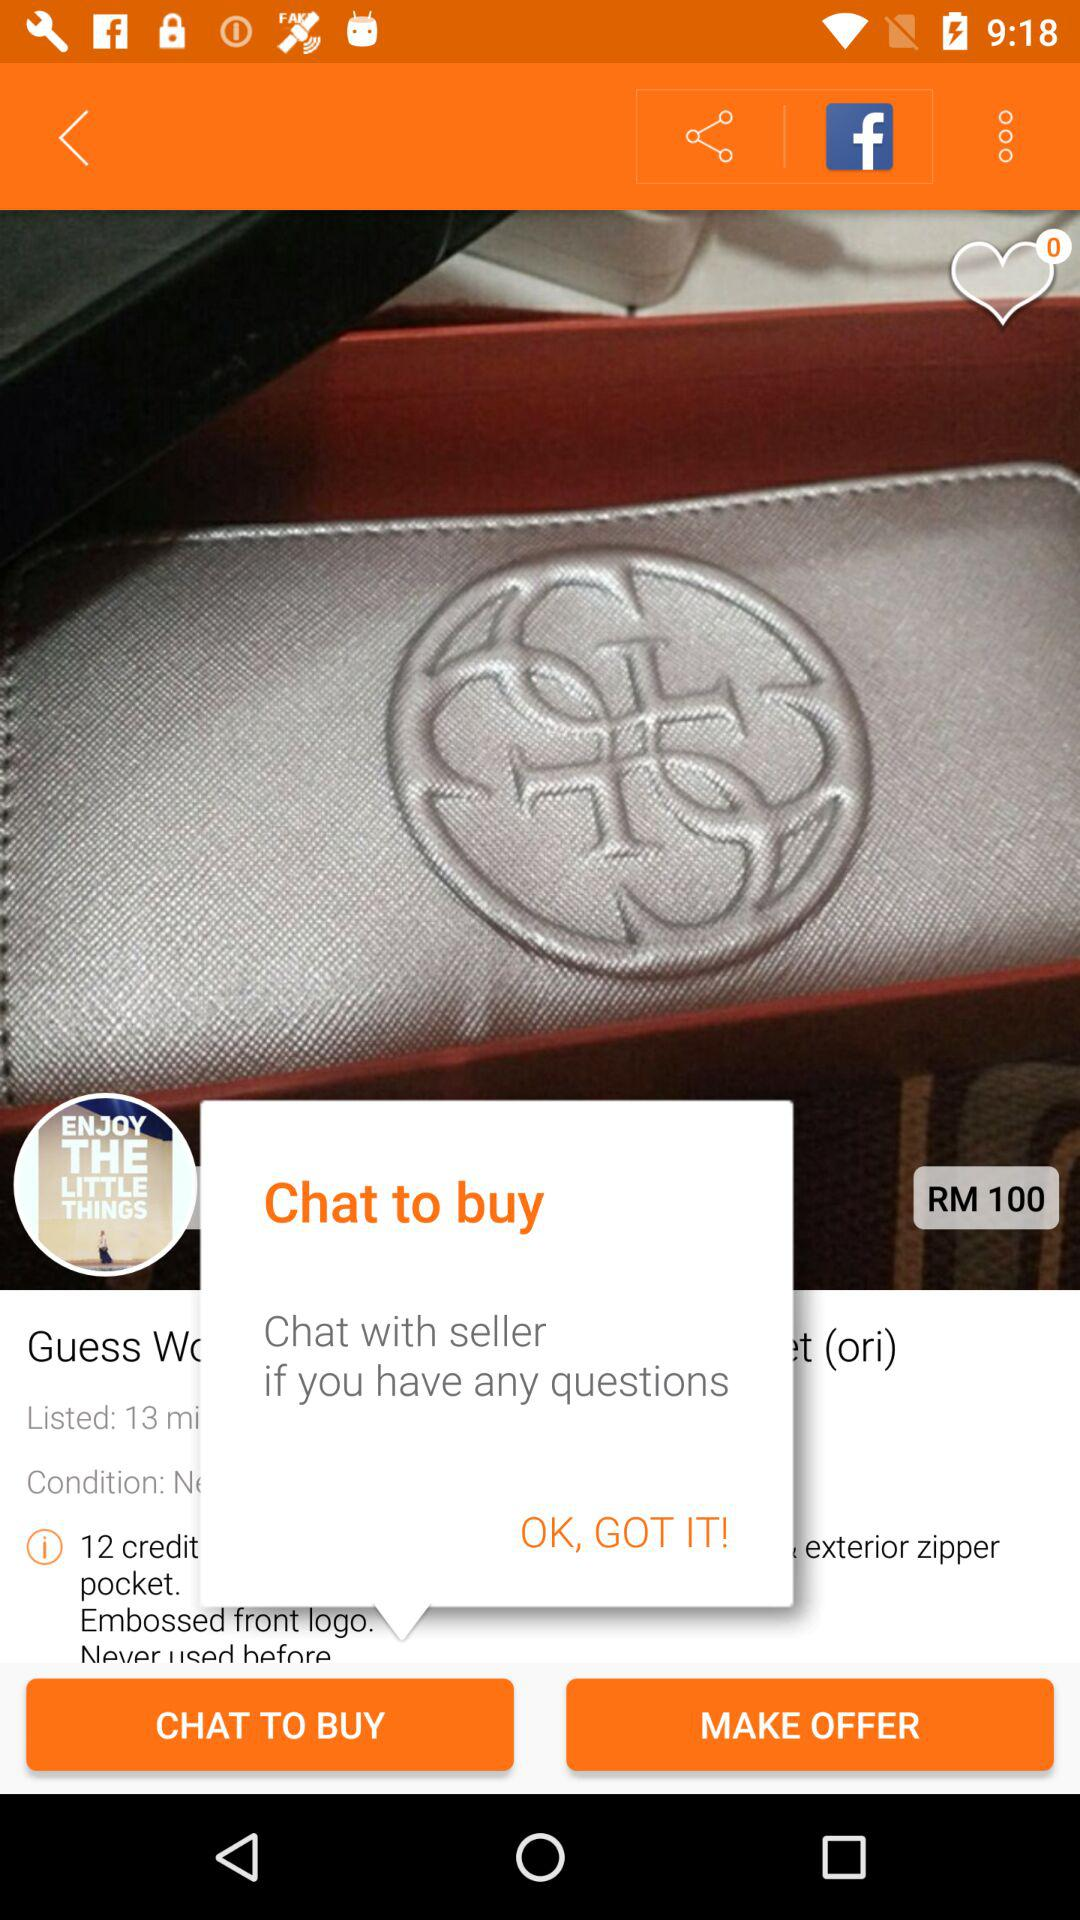How many likes are shown on the product? There are 0 likes on the product. 